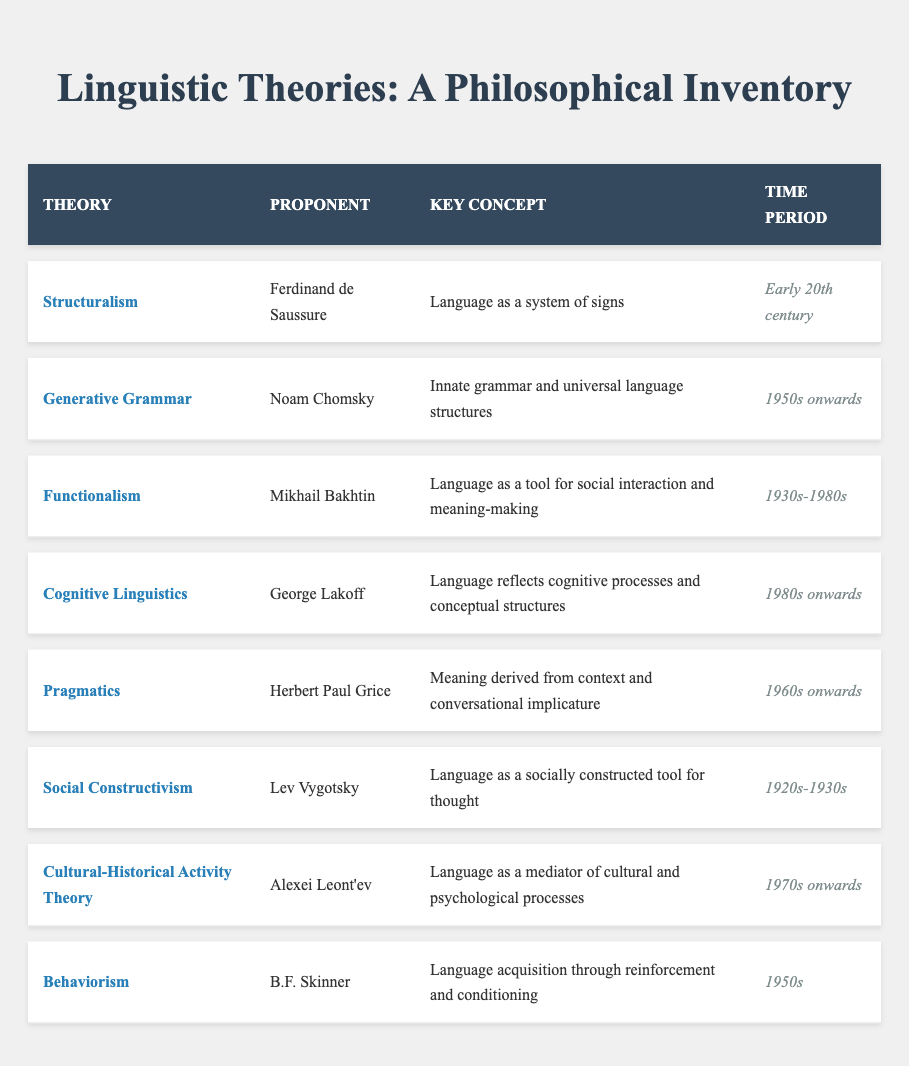What is the key concept behind Generative Grammar? The table shows that the key concept for Generative Grammar, as proposed by Noam Chomsky, is "Innate grammar and universal language structures." This is a direct retrieval from the table.
Answer: Innate grammar and universal language structures Who is the proponent of Pragmatics? The table indicates that Herbert Paul Grice is the proponent associated with Pragmatics. This can be directly found in the proponent column under the Pragmatics row.
Answer: Herbert Paul Grice How many theories were proposed during the 1950s? From the table, two theories are associated with the 1950s: Generative Grammar and Behaviorism. Thus, the count is 2.
Answer: 2 Is Structuralism related to language as a socially constructed tool for thought? The table shows that Structuralism, proposed by Ferdinand de Saussure, is based on the idea of "Language as a system of signs," which does not align with the concept of language being socially constructed according to Lev Vygotsky's Social Constructivism. Hence, the answer is no.
Answer: No Which linguistic theory spans the broadest time period? By examining the time periods, Functionalism spans from the 1930s to the 1980s, which is the longest among the listed theories. This involves comparing time frames accordingly.
Answer: Functionalism What does Cognitive Linguistics suggest about language? The table indicates that Cognitive Linguistics, as proposed by George Lakoff, reflects cognitive processes and conceptual structures, directly retrieved from the corresponding segments in the table.
Answer: Language reflects cognitive processes and conceptual structures Are there any theories proposed after the 1980s? The table lists Cognitive Linguistics and Cultural-Historical Activity Theory, both of which appear post-1980s, making the answer yes. This is a simple yes/no question based on retrieval from the time period column.
Answer: Yes Which two theories focus on social interaction? By checking the key concepts, both Functionalism (Mikhail Bakhtin) and Social Constructivism (Lev Vygotsky) address language as a tool for social interaction and thought. This requires identifying related concepts from the table.
Answer: Functionalism and Social Constructivism 